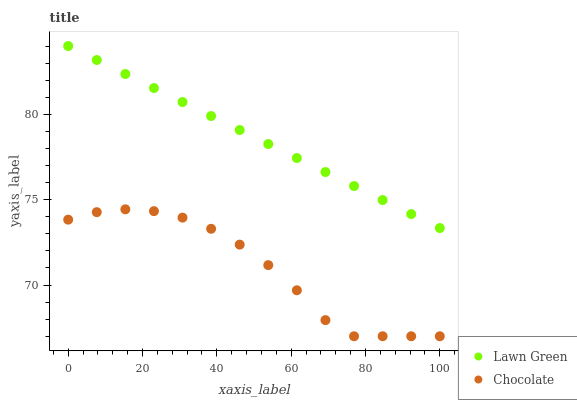Does Chocolate have the minimum area under the curve?
Answer yes or no. Yes. Does Lawn Green have the maximum area under the curve?
Answer yes or no. Yes. Does Chocolate have the maximum area under the curve?
Answer yes or no. No. Is Lawn Green the smoothest?
Answer yes or no. Yes. Is Chocolate the roughest?
Answer yes or no. Yes. Is Chocolate the smoothest?
Answer yes or no. No. Does Chocolate have the lowest value?
Answer yes or no. Yes. Does Lawn Green have the highest value?
Answer yes or no. Yes. Does Chocolate have the highest value?
Answer yes or no. No. Is Chocolate less than Lawn Green?
Answer yes or no. Yes. Is Lawn Green greater than Chocolate?
Answer yes or no. Yes. Does Chocolate intersect Lawn Green?
Answer yes or no. No. 